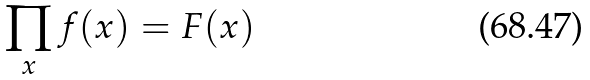<formula> <loc_0><loc_0><loc_500><loc_500>\prod _ { x } f ( x ) = F ( x )</formula> 